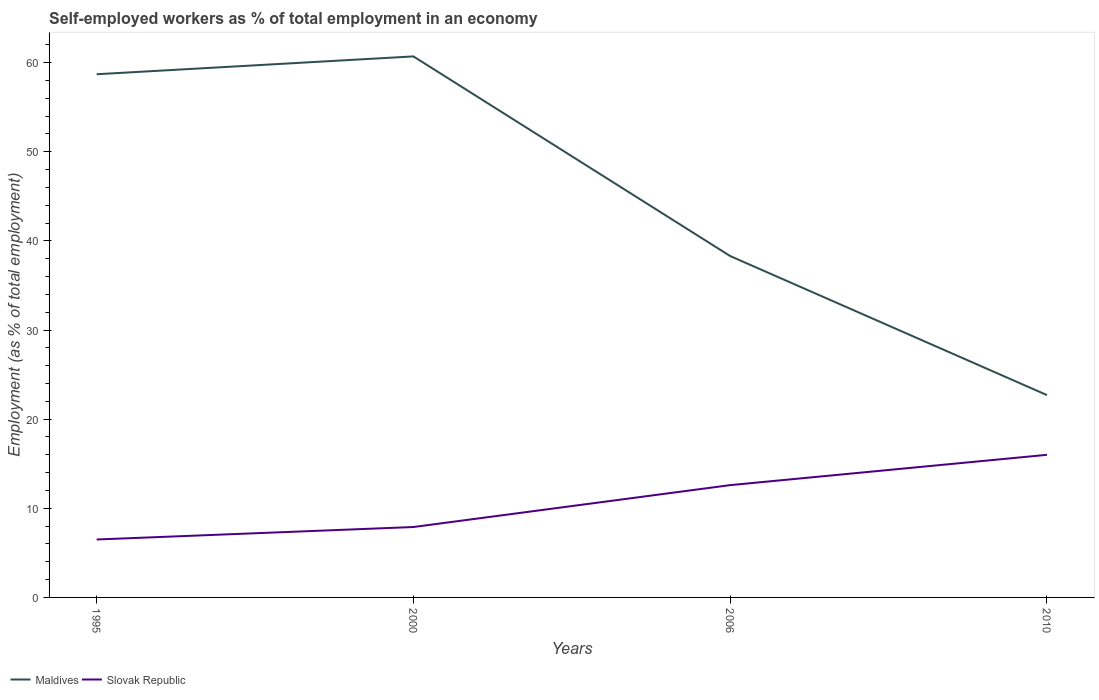Does the line corresponding to Slovak Republic intersect with the line corresponding to Maldives?
Provide a succinct answer. No. Is the number of lines equal to the number of legend labels?
Your answer should be compact. Yes. Across all years, what is the maximum percentage of self-employed workers in Maldives?
Provide a short and direct response. 22.7. What is the total percentage of self-employed workers in Slovak Republic in the graph?
Your answer should be compact. -6.1. Is the percentage of self-employed workers in Slovak Republic strictly greater than the percentage of self-employed workers in Maldives over the years?
Ensure brevity in your answer.  Yes. How many lines are there?
Ensure brevity in your answer.  2. Where does the legend appear in the graph?
Provide a succinct answer. Bottom left. How many legend labels are there?
Your answer should be very brief. 2. What is the title of the graph?
Ensure brevity in your answer.  Self-employed workers as % of total employment in an economy. What is the label or title of the X-axis?
Give a very brief answer. Years. What is the label or title of the Y-axis?
Your answer should be compact. Employment (as % of total employment). What is the Employment (as % of total employment) in Maldives in 1995?
Ensure brevity in your answer.  58.7. What is the Employment (as % of total employment) of Slovak Republic in 1995?
Make the answer very short. 6.5. What is the Employment (as % of total employment) of Maldives in 2000?
Your answer should be compact. 60.7. What is the Employment (as % of total employment) of Slovak Republic in 2000?
Offer a terse response. 7.9. What is the Employment (as % of total employment) of Maldives in 2006?
Offer a terse response. 38.3. What is the Employment (as % of total employment) of Slovak Republic in 2006?
Provide a short and direct response. 12.6. What is the Employment (as % of total employment) of Maldives in 2010?
Offer a terse response. 22.7. What is the Employment (as % of total employment) in Slovak Republic in 2010?
Give a very brief answer. 16. Across all years, what is the maximum Employment (as % of total employment) in Maldives?
Your answer should be very brief. 60.7. Across all years, what is the maximum Employment (as % of total employment) of Slovak Republic?
Ensure brevity in your answer.  16. Across all years, what is the minimum Employment (as % of total employment) of Maldives?
Your response must be concise. 22.7. Across all years, what is the minimum Employment (as % of total employment) in Slovak Republic?
Your response must be concise. 6.5. What is the total Employment (as % of total employment) of Maldives in the graph?
Provide a succinct answer. 180.4. What is the total Employment (as % of total employment) of Slovak Republic in the graph?
Offer a very short reply. 43. What is the difference between the Employment (as % of total employment) of Maldives in 1995 and that in 2006?
Give a very brief answer. 20.4. What is the difference between the Employment (as % of total employment) in Maldives in 1995 and that in 2010?
Make the answer very short. 36. What is the difference between the Employment (as % of total employment) of Maldives in 2000 and that in 2006?
Make the answer very short. 22.4. What is the difference between the Employment (as % of total employment) in Slovak Republic in 2000 and that in 2006?
Offer a very short reply. -4.7. What is the difference between the Employment (as % of total employment) of Maldives in 2000 and that in 2010?
Provide a succinct answer. 38. What is the difference between the Employment (as % of total employment) in Maldives in 2006 and that in 2010?
Ensure brevity in your answer.  15.6. What is the difference between the Employment (as % of total employment) in Maldives in 1995 and the Employment (as % of total employment) in Slovak Republic in 2000?
Keep it short and to the point. 50.8. What is the difference between the Employment (as % of total employment) of Maldives in 1995 and the Employment (as % of total employment) of Slovak Republic in 2006?
Give a very brief answer. 46.1. What is the difference between the Employment (as % of total employment) of Maldives in 1995 and the Employment (as % of total employment) of Slovak Republic in 2010?
Offer a very short reply. 42.7. What is the difference between the Employment (as % of total employment) in Maldives in 2000 and the Employment (as % of total employment) in Slovak Republic in 2006?
Offer a very short reply. 48.1. What is the difference between the Employment (as % of total employment) of Maldives in 2000 and the Employment (as % of total employment) of Slovak Republic in 2010?
Keep it short and to the point. 44.7. What is the difference between the Employment (as % of total employment) of Maldives in 2006 and the Employment (as % of total employment) of Slovak Republic in 2010?
Offer a terse response. 22.3. What is the average Employment (as % of total employment) in Maldives per year?
Ensure brevity in your answer.  45.1. What is the average Employment (as % of total employment) of Slovak Republic per year?
Keep it short and to the point. 10.75. In the year 1995, what is the difference between the Employment (as % of total employment) of Maldives and Employment (as % of total employment) of Slovak Republic?
Your answer should be very brief. 52.2. In the year 2000, what is the difference between the Employment (as % of total employment) of Maldives and Employment (as % of total employment) of Slovak Republic?
Your response must be concise. 52.8. In the year 2006, what is the difference between the Employment (as % of total employment) of Maldives and Employment (as % of total employment) of Slovak Republic?
Provide a succinct answer. 25.7. What is the ratio of the Employment (as % of total employment) in Maldives in 1995 to that in 2000?
Offer a very short reply. 0.97. What is the ratio of the Employment (as % of total employment) of Slovak Republic in 1995 to that in 2000?
Offer a terse response. 0.82. What is the ratio of the Employment (as % of total employment) in Maldives in 1995 to that in 2006?
Offer a very short reply. 1.53. What is the ratio of the Employment (as % of total employment) of Slovak Republic in 1995 to that in 2006?
Provide a short and direct response. 0.52. What is the ratio of the Employment (as % of total employment) of Maldives in 1995 to that in 2010?
Give a very brief answer. 2.59. What is the ratio of the Employment (as % of total employment) in Slovak Republic in 1995 to that in 2010?
Your answer should be compact. 0.41. What is the ratio of the Employment (as % of total employment) of Maldives in 2000 to that in 2006?
Provide a short and direct response. 1.58. What is the ratio of the Employment (as % of total employment) in Slovak Republic in 2000 to that in 2006?
Make the answer very short. 0.63. What is the ratio of the Employment (as % of total employment) in Maldives in 2000 to that in 2010?
Give a very brief answer. 2.67. What is the ratio of the Employment (as % of total employment) in Slovak Republic in 2000 to that in 2010?
Give a very brief answer. 0.49. What is the ratio of the Employment (as % of total employment) in Maldives in 2006 to that in 2010?
Ensure brevity in your answer.  1.69. What is the ratio of the Employment (as % of total employment) in Slovak Republic in 2006 to that in 2010?
Provide a short and direct response. 0.79. What is the difference between the highest and the second highest Employment (as % of total employment) in Maldives?
Ensure brevity in your answer.  2. What is the difference between the highest and the lowest Employment (as % of total employment) in Maldives?
Make the answer very short. 38. What is the difference between the highest and the lowest Employment (as % of total employment) of Slovak Republic?
Your answer should be very brief. 9.5. 